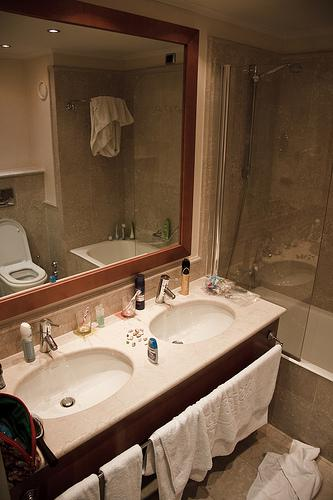Question: what color are the sinks?
Choices:
A. Silver.
B. White.
C. Black.
D. Green.
Answer with the letter. Answer: B Question: where are the sinks?
Choices:
A. Below the mirror.
B. Under the window.
C. In front of the toilet.
D. Next to the tub.
Answer with the letter. Answer: A Question: what is on the floor?
Choices:
A. Dirty clothes.
B. A towel.
C. Legos.
D. Feathers.
Answer with the letter. Answer: B 